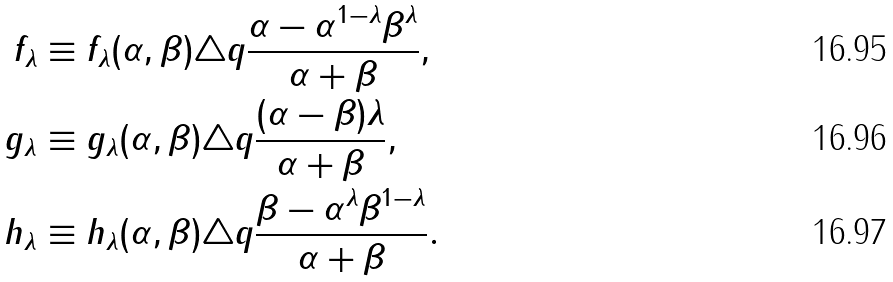Convert formula to latex. <formula><loc_0><loc_0><loc_500><loc_500>f _ { \lambda } & \equiv f _ { \lambda } ( \alpha , \beta ) \triangle q \frac { \alpha - \alpha ^ { 1 - \lambda } \beta ^ { \lambda } } { \alpha + \beta } , \\ g _ { \lambda } & \equiv g _ { \lambda } ( \alpha , \beta ) \triangle q \frac { ( \alpha - \beta ) \lambda } { \alpha + \beta } , \\ h _ { \lambda } & \equiv h _ { \lambda } ( \alpha , \beta ) \triangle q \frac { \beta - \alpha ^ { \lambda } \beta ^ { 1 - \lambda } } { \alpha + \beta } .</formula> 